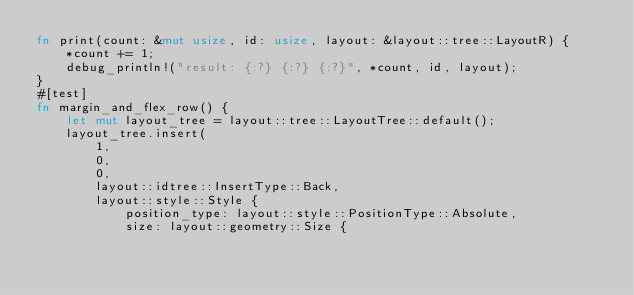<code> <loc_0><loc_0><loc_500><loc_500><_Rust_>fn print(count: &mut usize, id: usize, layout: &layout::tree::LayoutR) {
    *count += 1;
    debug_println!("result: {:?} {:?} {:?}", *count, id, layout);
}
#[test]
fn margin_and_flex_row() {
    let mut layout_tree = layout::tree::LayoutTree::default();
    layout_tree.insert(
        1,
        0,
        0,
        layout::idtree::InsertType::Back,
        layout::style::Style {
            position_type: layout::style::PositionType::Absolute,
            size: layout::geometry::Size {</code> 